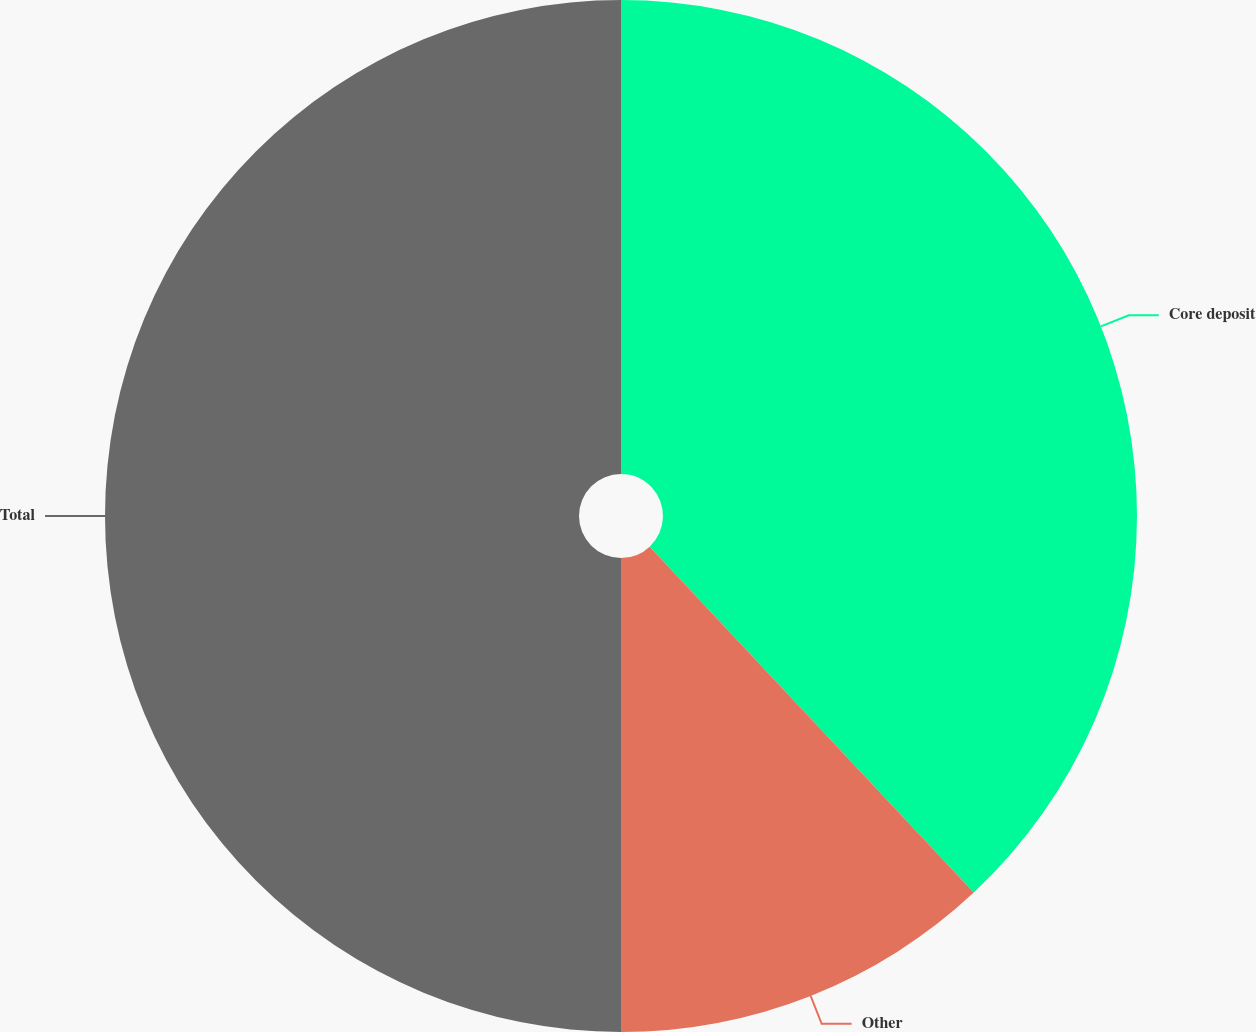Convert chart to OTSL. <chart><loc_0><loc_0><loc_500><loc_500><pie_chart><fcel>Core deposit<fcel>Other<fcel>Total<nl><fcel>38.02%<fcel>11.98%<fcel>50.0%<nl></chart> 